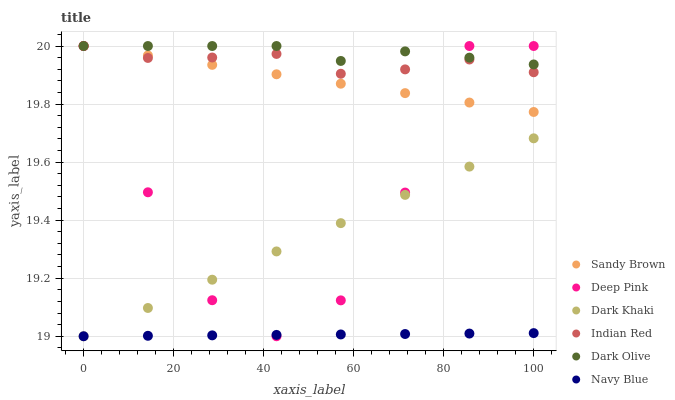Does Navy Blue have the minimum area under the curve?
Answer yes or no. Yes. Does Dark Olive have the maximum area under the curve?
Answer yes or no. Yes. Does Dark Olive have the minimum area under the curve?
Answer yes or no. No. Does Navy Blue have the maximum area under the curve?
Answer yes or no. No. Is Sandy Brown the smoothest?
Answer yes or no. Yes. Is Deep Pink the roughest?
Answer yes or no. Yes. Is Navy Blue the smoothest?
Answer yes or no. No. Is Navy Blue the roughest?
Answer yes or no. No. Does Navy Blue have the lowest value?
Answer yes or no. Yes. Does Dark Olive have the lowest value?
Answer yes or no. No. Does Sandy Brown have the highest value?
Answer yes or no. Yes. Does Navy Blue have the highest value?
Answer yes or no. No. Is Dark Khaki less than Sandy Brown?
Answer yes or no. Yes. Is Dark Olive greater than Navy Blue?
Answer yes or no. Yes. Does Indian Red intersect Sandy Brown?
Answer yes or no. Yes. Is Indian Red less than Sandy Brown?
Answer yes or no. No. Is Indian Red greater than Sandy Brown?
Answer yes or no. No. Does Dark Khaki intersect Sandy Brown?
Answer yes or no. No. 